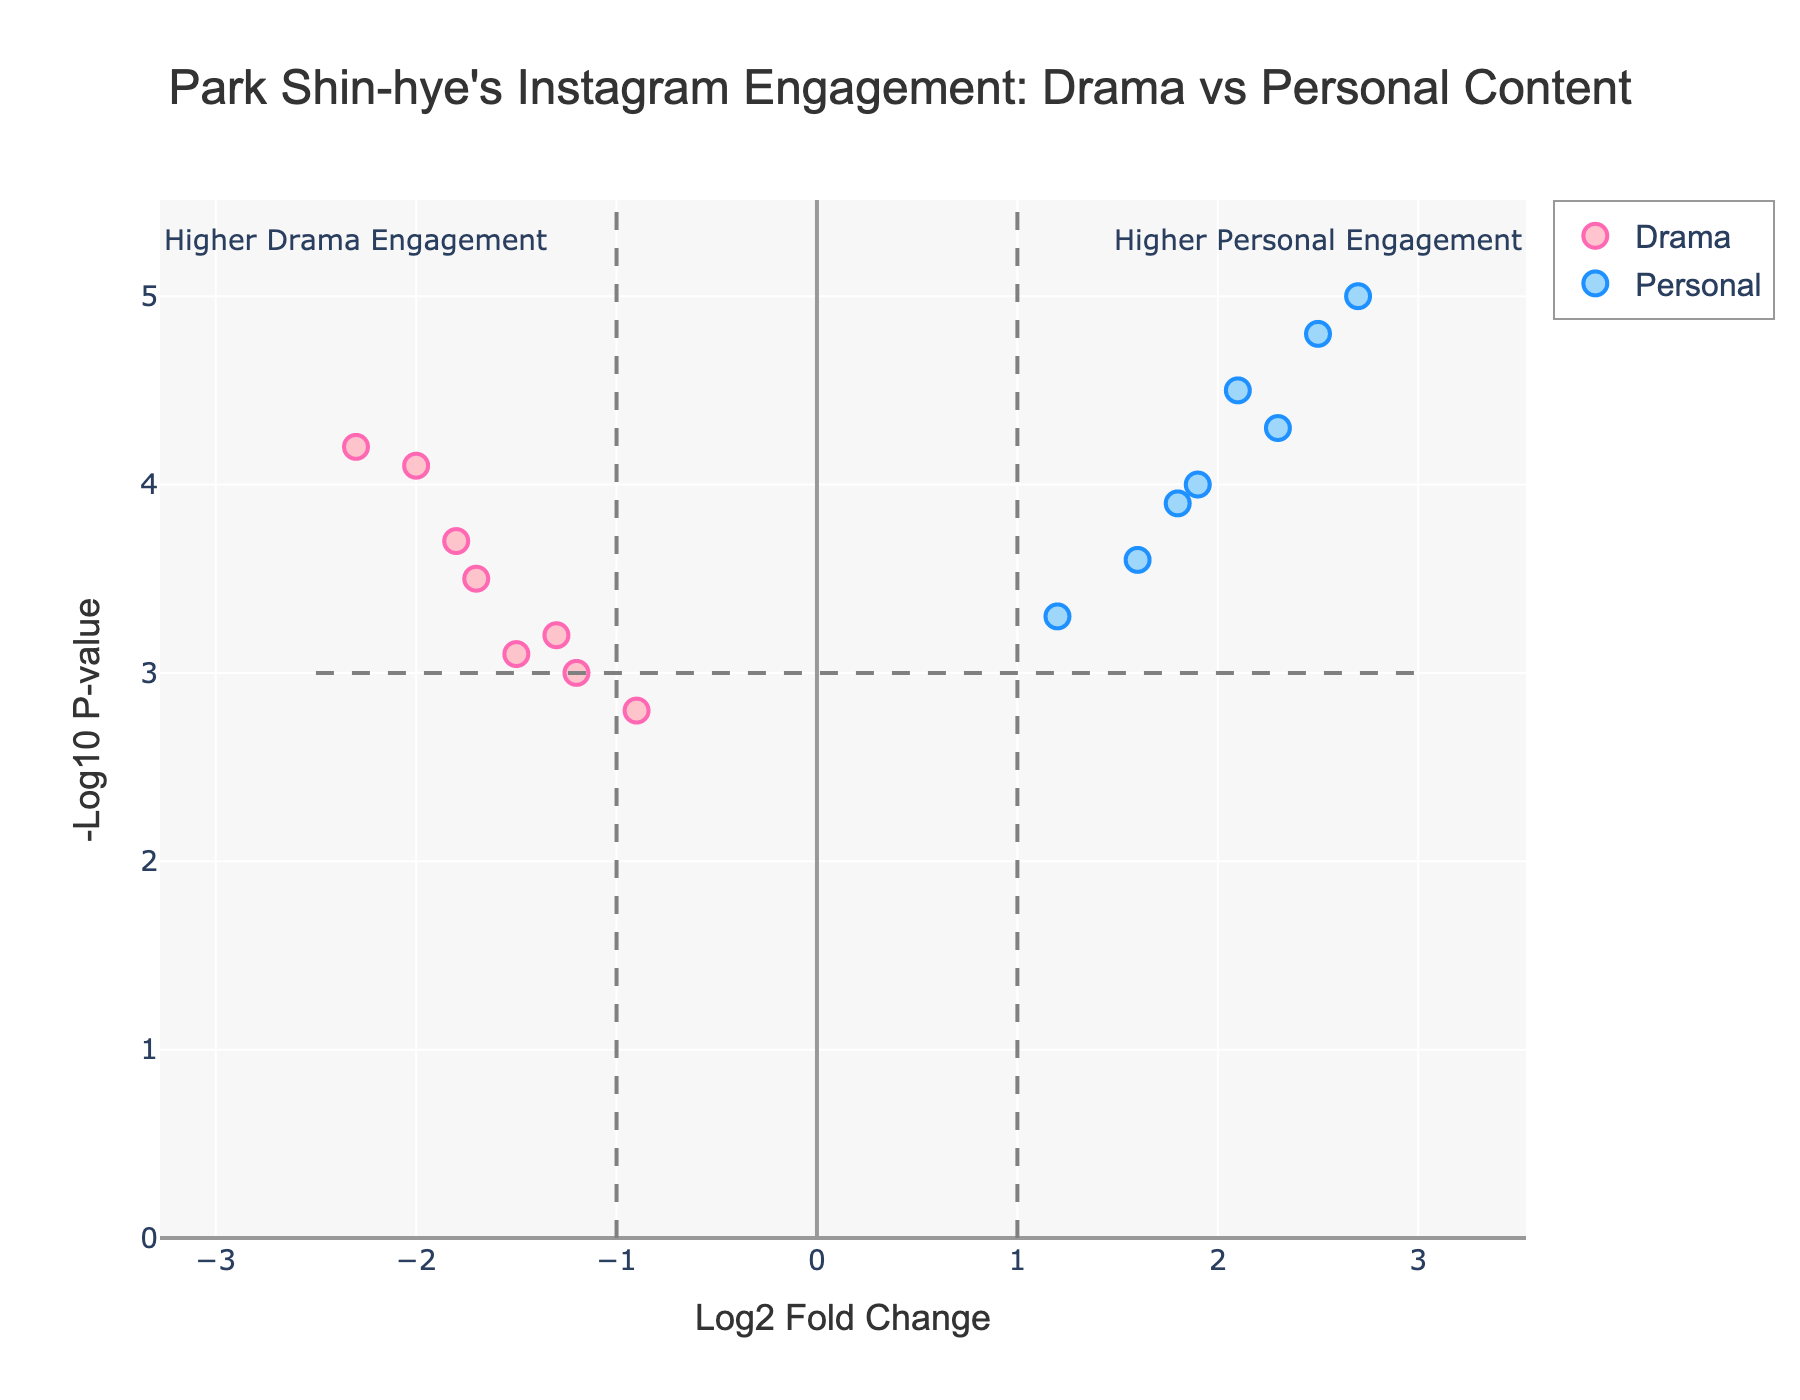what is the title of the figure? The title of the figure is positioned at the top center. It provides an overview of the plot and reads: "Park Shin-hye's Instagram Engagement: Drama vs Personal Content."
Answer: Park Shin-hye's Instagram Engagement: Drama vs Personal Content which data point has the highest -log10 P-value? To find this, check which point has the highest position on the y-axis. The 'Personal' post "Makeup-free selfie" with a y-value of 5.0 appears the highest on the y-axis.
Answer: Makeup-free selfie what is the post type for the data point with the highest log2 Fold Change? Look at the x-axis to identify the highest value, and find which data point it corresponds to. The 'Personal' post "Makeup-free selfie" has the highest log2 Fold Change of 2.7.
Answer: Personal how many data points represent drama posts? Count the number of data points that fall under the 'Drama' category. By observing the colors and markers, we can see there are 8 such data points.
Answer: 8 based on the plot, do more personal posts have higher engagement than drama posts? To determine this, compare the distribution of personal posts and drama posts along the log2 Fold Change axis. Most personal posts are on the positive side, indicating higher engagement, whereas most drama posts are on the negative side.
Answer: Yes which personal post has the lowest engagement according to log2 Fold Change? Examine the personal posts and identify which one is closest to zero or negative on the x-axis. The 'Charity event appearance' has a log2 Fold Change of 1.2, the lowest among personal posts.
Answer: Charity event appearance what fraction of the drama posts have a -log10 P-value higher than 3.0? First, identify how many drama posts have a -log10 P-value greater than 3.0. There are 6 such posts out of 8 drama posts. The fraction is therefore 6/8, which simplifies to 3/4.
Answer: 3/4 what is the content of the drama post with the highest engagement? Find the drama post with the highest log2 Fold Change. The 'The Heirs behind-the-scenes photo' has a log2 Fold Change of -2.3, the highest negative change among drama posts.
Answer: The Heirs behind-the-scenes photo is there a clear separation between personal and drama post engagement levels? To determine this, observe the distribution along the log2 Fold Change axis. Personal posts generally have positive values, whereas drama posts have negative values, showing a clear separation.
Answer: Yes compare the median -log10 P-value of personal posts with drama posts. Arrange all the -log10 P-values for personal and drama posts separately and find the median value of each set. The median -log10 P-value for personal posts is 4.35, and for drama posts is 3.3.
Answer: Personal: 4.35, Drama: 3.3 